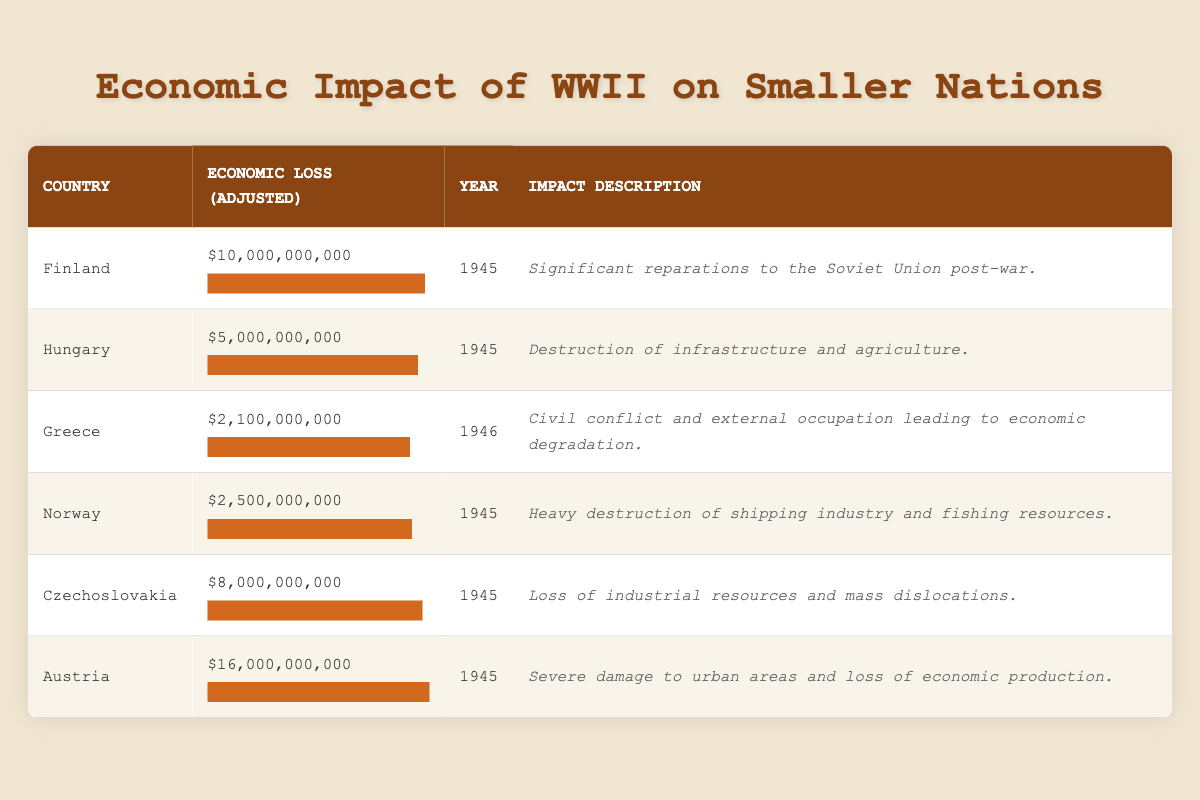What is the economic loss for Finland in inflation-adjusted dollars? The table shows that the economic loss for Finland is listed as $10,000,000,000 in the respective column.
Answer: 10,000,000,000 Which country experienced the greatest economic loss due to WWII? By comparing the economic loss figures in the table, Austria has the highest loss of $16,000,000,000.
Answer: Austria What was the total economic loss in inflation-adjusted dollars for Greece and Norway combined? The economic loss for Greece is $2,100,000,000 and for Norway is $2,500,000,000. Adding these gives a total loss of $2,100,000,000 + $2,500,000,000 = $4,600,000,000.
Answer: 4,600,000,000 Did Hungary suffer more economic loss than Greece? The table shows Hungary's economic loss as $5,000,000,000 and Greece's as $2,100,000,000. Since $5,000,000,000 is greater than $2,100,000,000, the statement is true.
Answer: Yes What is the average economic loss for the countries listed in the table? To find the average, sum the economic losses: $10,000,000,000 + $5,000,000,000 + $2,100,000,000 + $2,500,000,000 + $8,000,000,000 + $16,000,000,000 = $43,600,000,000. There are six countries, so divide by 6 which gives $43,600,000,000 / 6 = $7,266,666,666.67. For simplicity, we can round this to $7,266,666,667.
Answer: 7,266,666,667 What economic impact did Czechoslovakia face in 1945? The table states that Czechoslovakia suffered an economic loss of $8,000,000,000 in 1945, and the impact description indicates loss of industrial resources and mass dislocations.
Answer: 8,000,000,000 